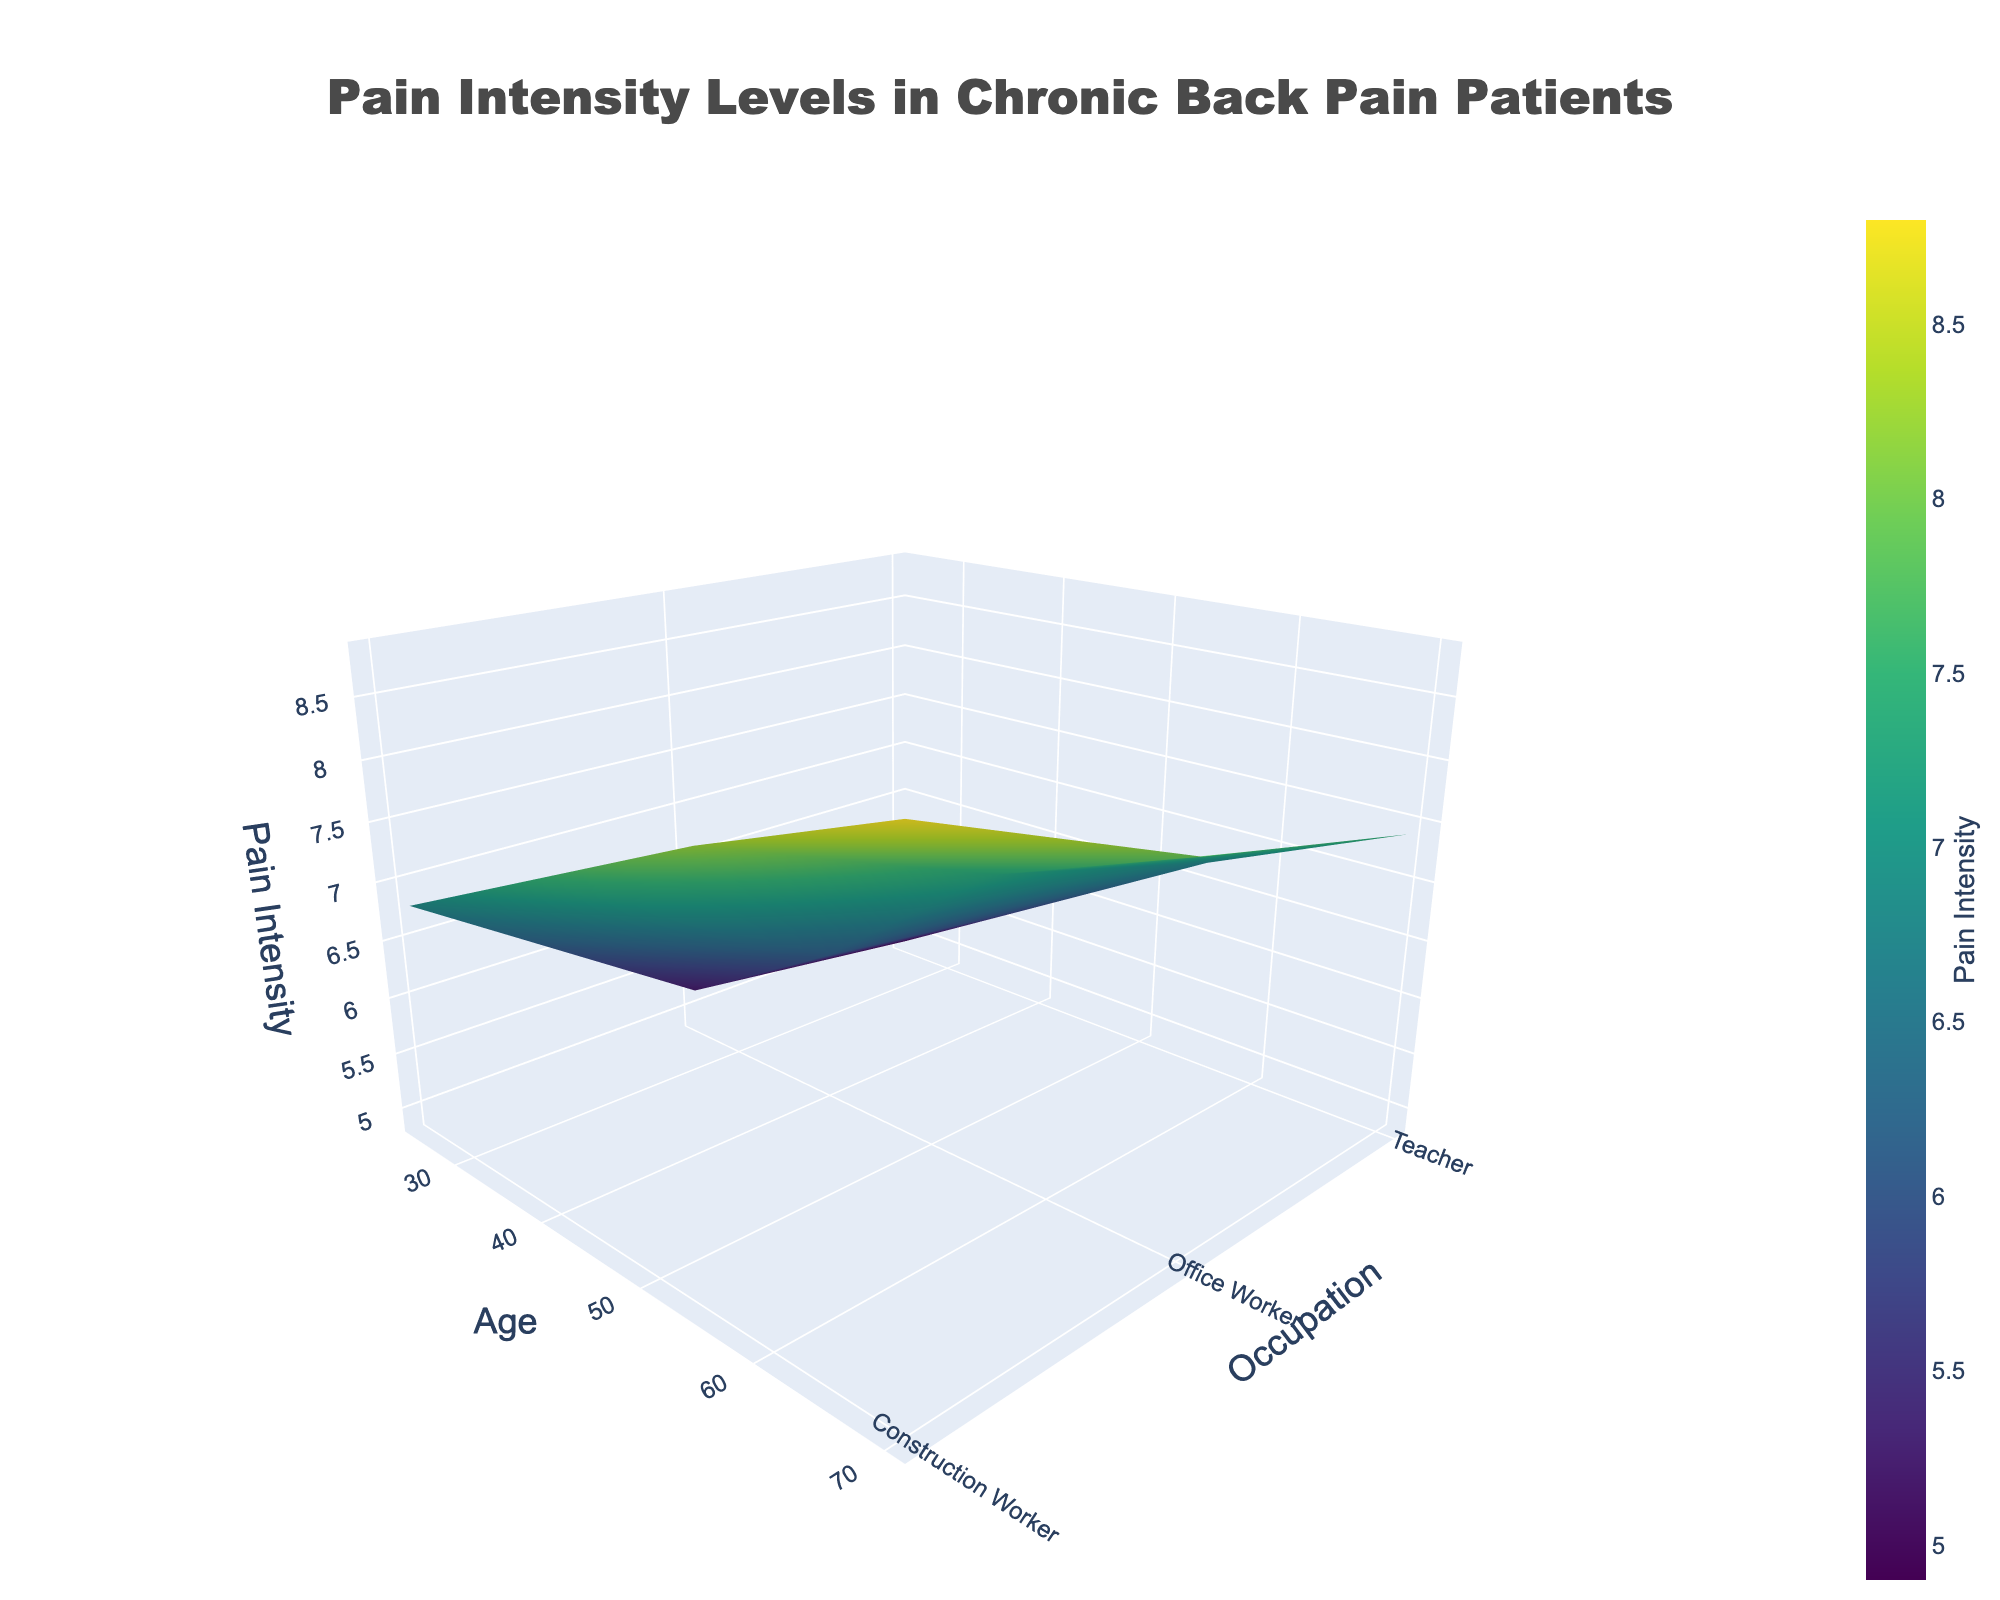What's the title of the figure? The title of the figure is usually prominently displayed at the top center of the plot. In this case, looking at the generated layout, the title is in a large, noticeable font.
Answer: Pain Intensity Levels in Chronic Back Pain Patients What are the labels of the axes? The axis labels are generally provided to explain what each axis represents. This can be seen in the layout updates where the x-axis, y-axis, and z-axis titles are defined.
Answer: Age, Occupation, Pain Intensity Which occupation and age group has the highest reported pain intensity? From the data and the pivoted 3D surface plot, the highest pain intensity can be identified by looking at the peak value in the plot, noting the corresponding age and occupation. The peak intensity is at the coordinate that aligns with the highest z-axis value.
Answer: Construction Worker, 70 How does pain intensity for office workers change with age? To understand the change in pain intensity for office workers, locate the plot corresponding to "Office Worker" and observe the trend along the age axis (x-axis). Pain intensity appears to increase with age.
Answer: It increases with age What is the difference in pain intensity between a 40-year-old teacher and a 55-year-old construction worker? To find this, identify the pain intensity for a 40-year-old teacher and a 55-year-old construction worker from the plot. Subtract the former's pain intensity from the latter's.
Answer: 8.2 - 5.8 = 2.4 For which occupation does age have the least impact on pain intensity? Viewing the figure, evaluate the slopes of the surfaces representing different occupations. The occupation with a relatively flatter slope indicates less variance in pain intensity over age.
Answer: Teacher Compare the pain intensity levels of a 25-year-old office worker and a 70-year-old teacher. Which is higher? Refer to the corresponding values on the plot for a 25-year-old office worker and a 70-year-old teacher. Compare the z-axis values (pain intensities).
Answer: 70-year-old teacher On average, does the pain intensity of teachers increase or decrease with age? To find the average trend, observe the pain intensity values for teachers across different ages and determine whether there's an upward or downward trajectory.
Answer: Increases with age Which occupation has the steepest increase in pain intensity with age? The steepest increase can be seen from the occupation that has the sharpest upward slope when plotted on the 3D surface plot. This represents the most significant rate of increase in pain intensity with age.
Answer: Construction Worker 